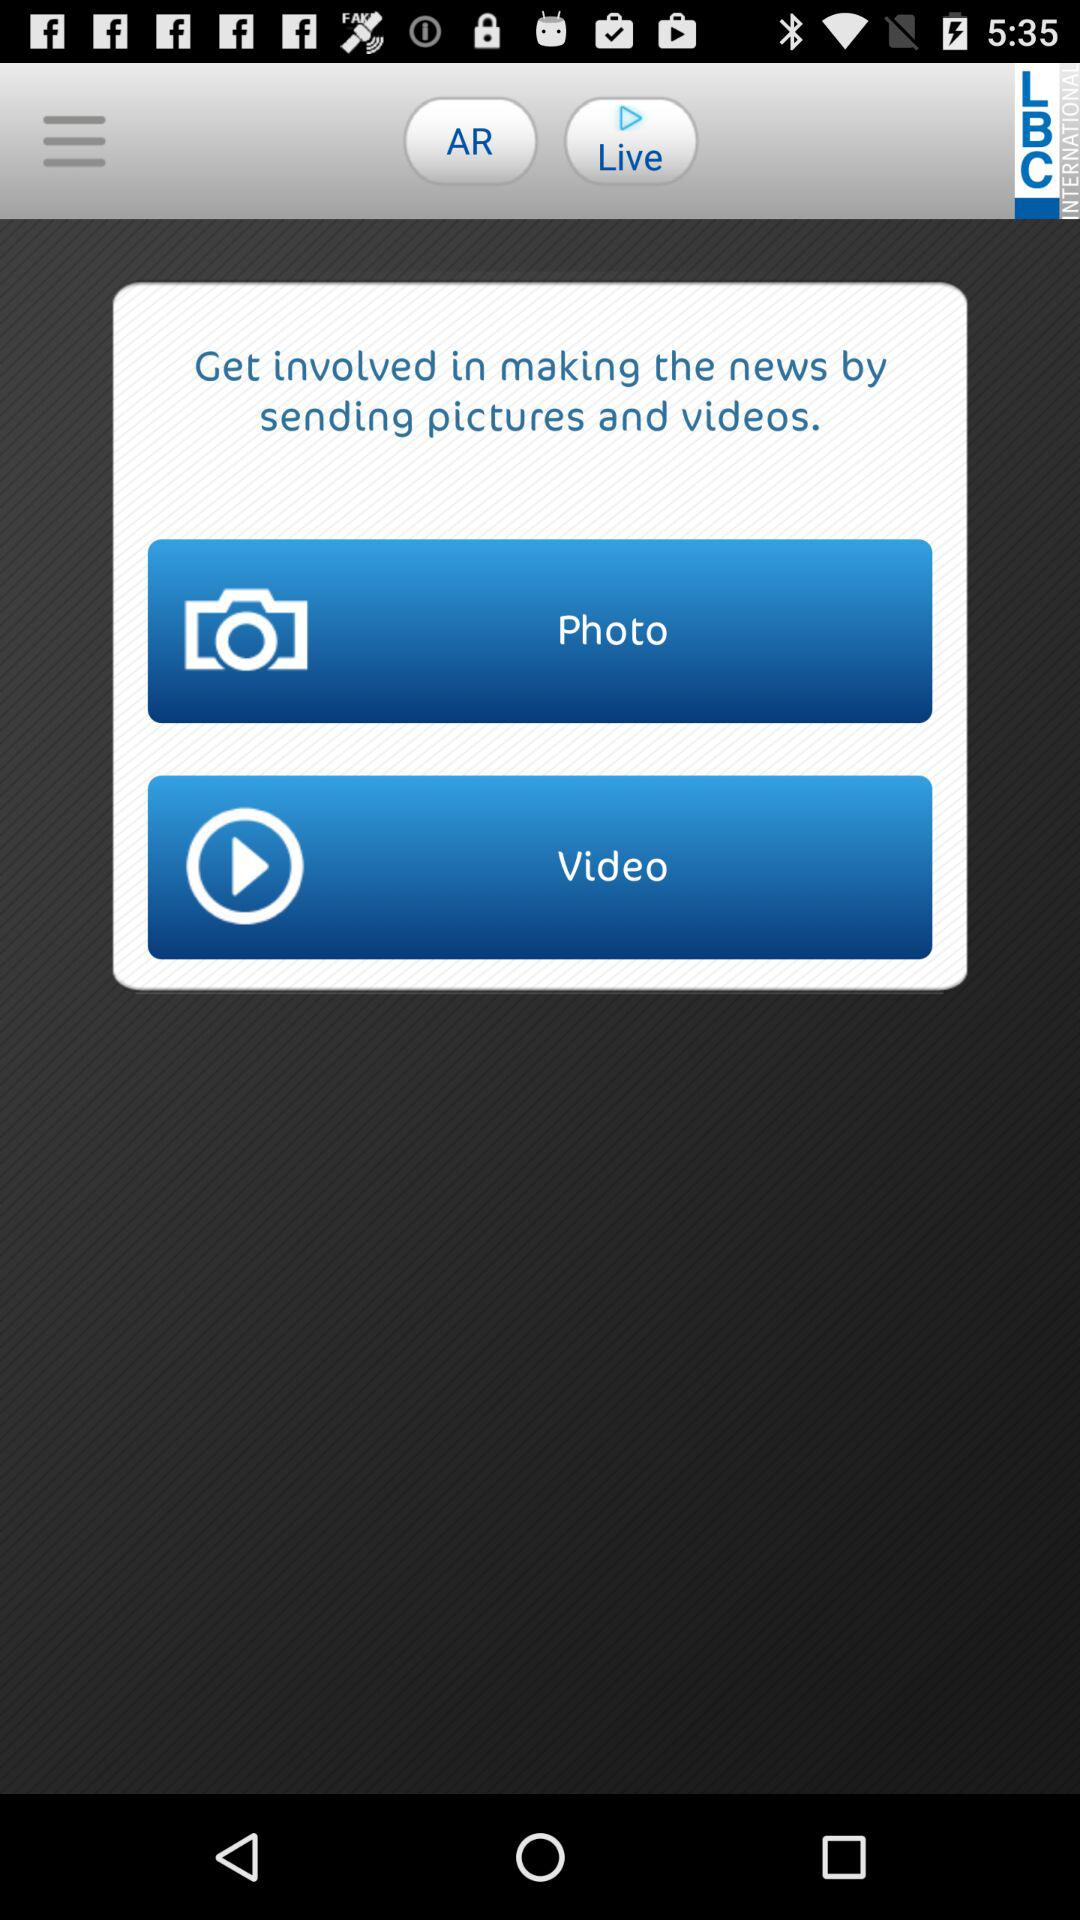What is the application name? The application name is "LBC INTERNATIONAL". 